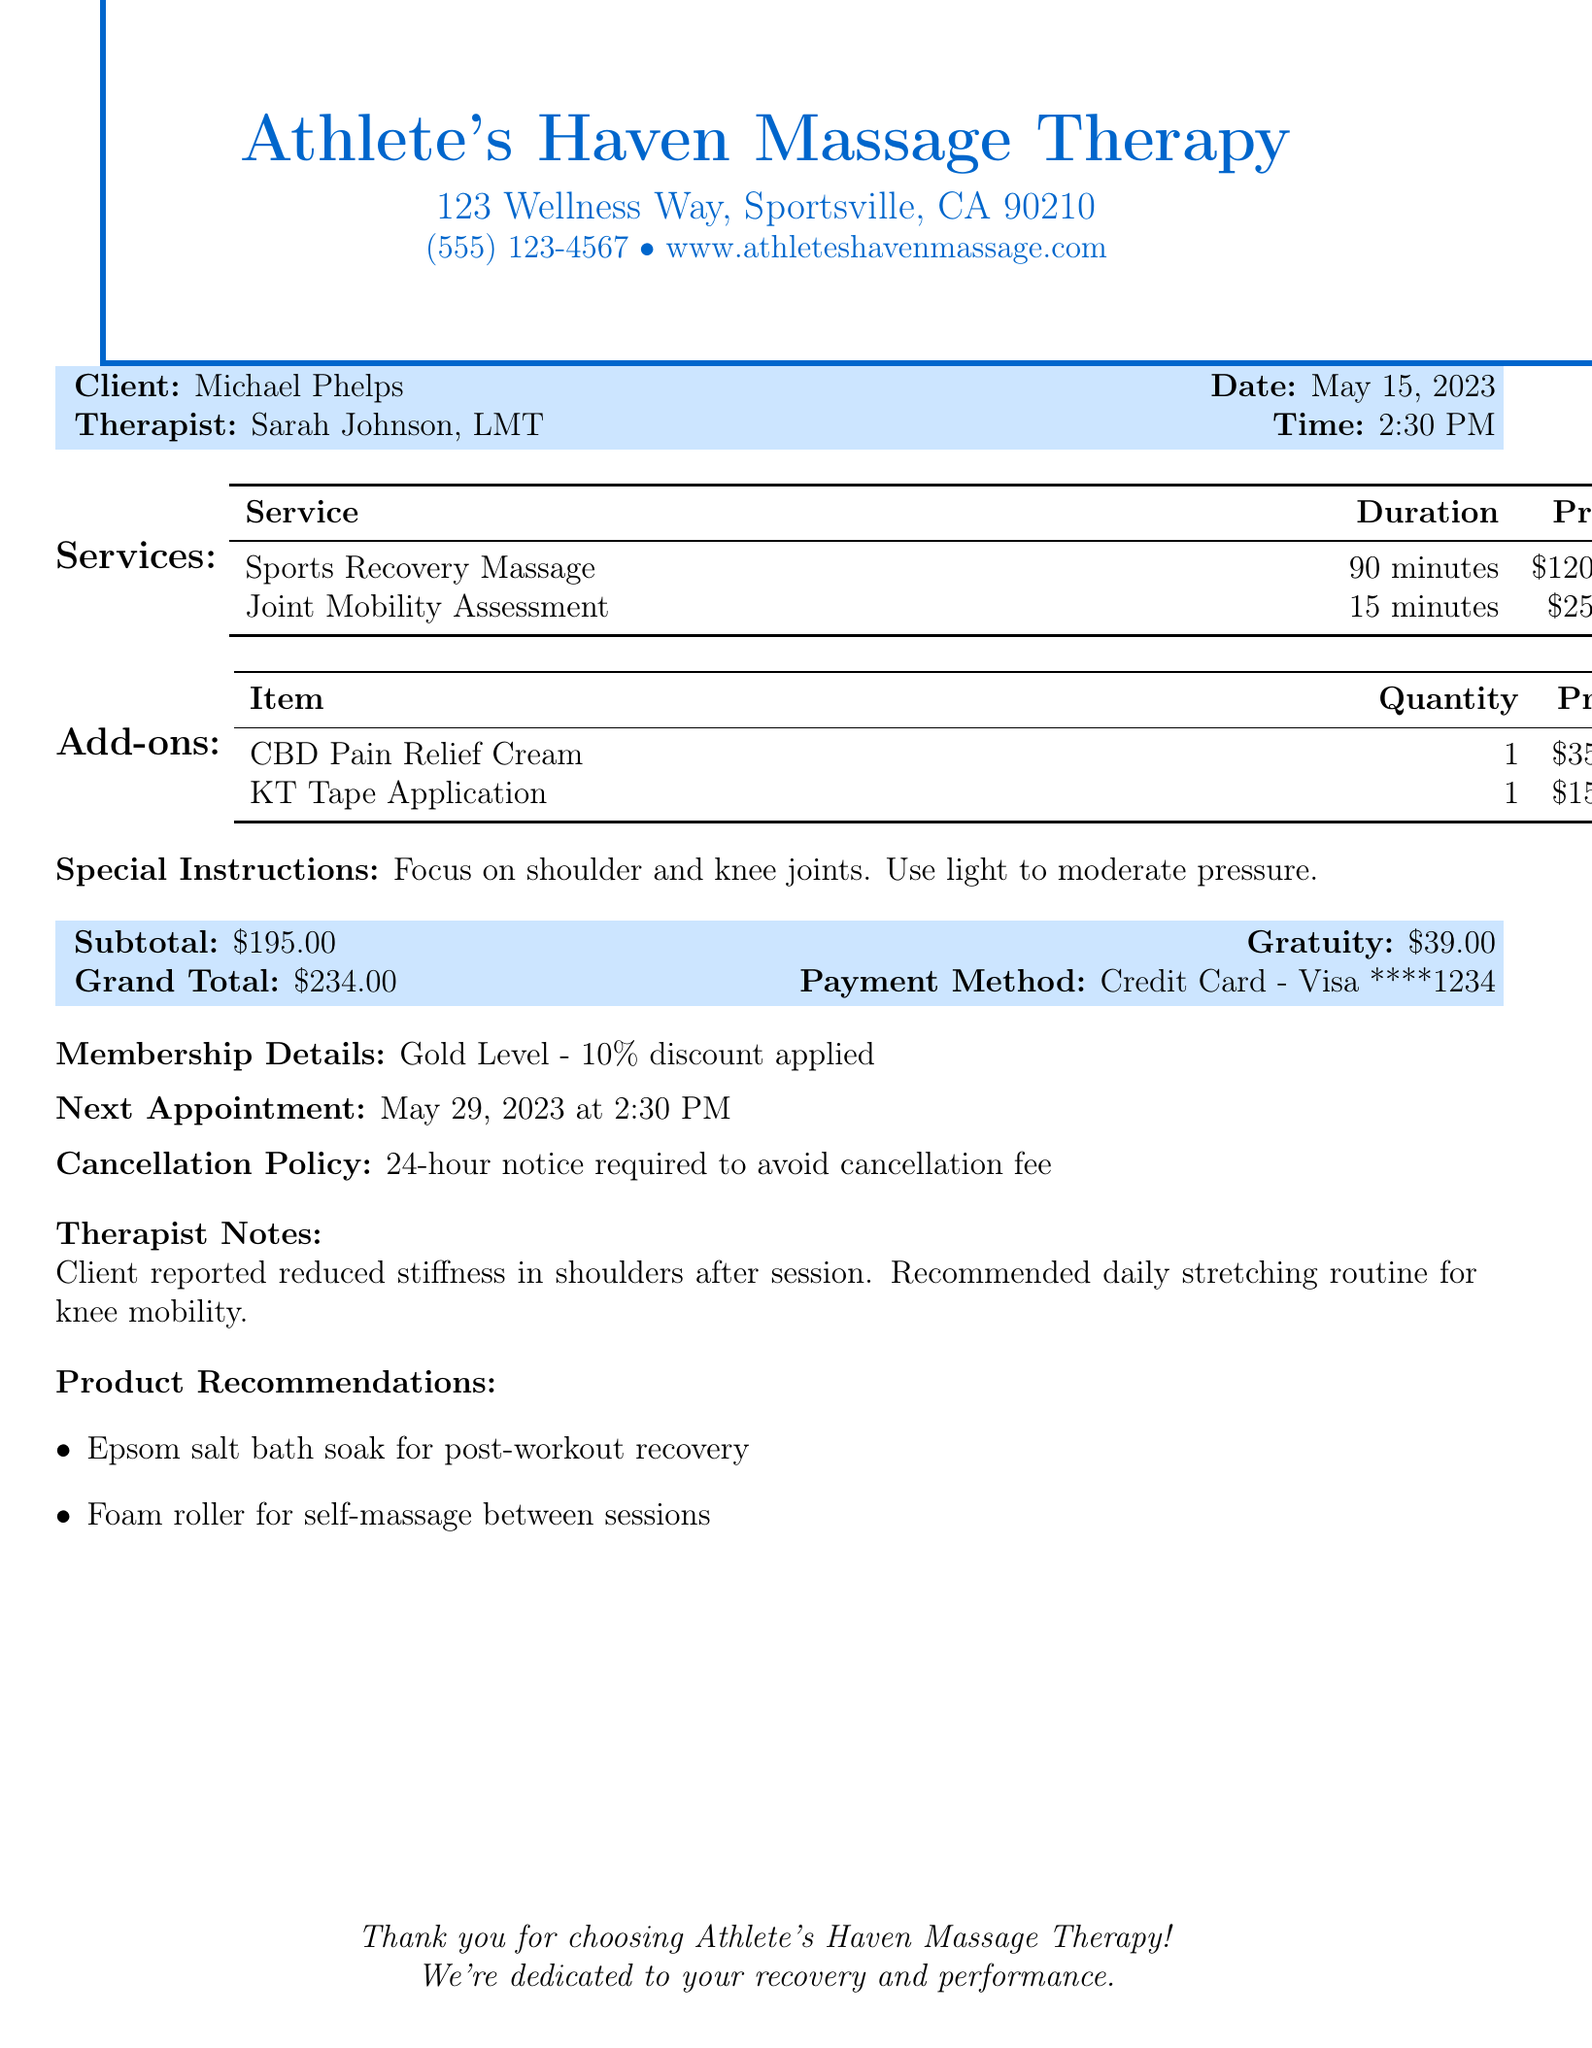What is the name of the massage therapy business? The business name is prominently displayed at the top of the receipt.
Answer: Athlete's Haven Massage Therapy Who is the therapist for this session? The therapist's name is included under the client details section.
Answer: Sarah Johnson, LMT What was the total price for the services? The total price is clearly indicated in the financial summary of the receipt.
Answer: $195.00 How much was the gratuity? The gratuity amount is specified in the payment summary section of the receipt.
Answer: $39.00 When is the next appointment scheduled? The next appointment date and time are provided near the bottom of the receipt.
Answer: May 29, 2023 at 2:30 PM What service had the longest duration? By comparing the durations listed, it's determined which service took more time.
Answer: Sports Recovery Massage What special instruction was given for the session? This information is explicitly stated in the special instructions section.
Answer: Focus on shoulder and knee joints. Use light to moderate pressure What is the cancellation policy? The cancellation policy is mentioned as a distinct statement on the receipt.
Answer: 24-hour notice required to avoid cancellation fee What product is recommended for post-workout recovery? The product recommendations section offers specific items for recovery.
Answer: Epsom salt bath soak How much was charged for the Joint Mobility Assessment? The price for this specific service is detailed in the services section of the receipt.
Answer: $25.00 